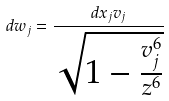Convert formula to latex. <formula><loc_0><loc_0><loc_500><loc_500>d w _ { j } = \frac { d x _ { j } v _ { j } } { \sqrt { 1 - \frac { v _ { j } ^ { 6 } } { z ^ { 6 } } } }</formula> 